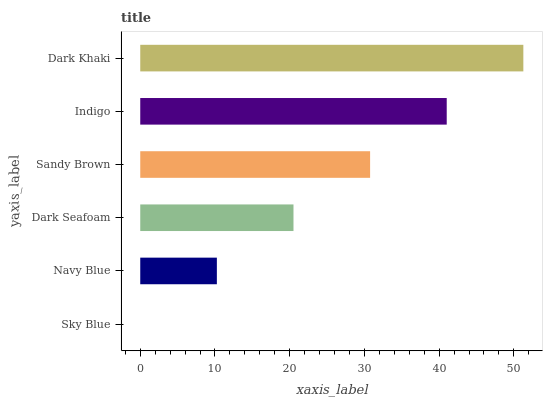Is Sky Blue the minimum?
Answer yes or no. Yes. Is Dark Khaki the maximum?
Answer yes or no. Yes. Is Navy Blue the minimum?
Answer yes or no. No. Is Navy Blue the maximum?
Answer yes or no. No. Is Navy Blue greater than Sky Blue?
Answer yes or no. Yes. Is Sky Blue less than Navy Blue?
Answer yes or no. Yes. Is Sky Blue greater than Navy Blue?
Answer yes or no. No. Is Navy Blue less than Sky Blue?
Answer yes or no. No. Is Sandy Brown the high median?
Answer yes or no. Yes. Is Dark Seafoam the low median?
Answer yes or no. Yes. Is Navy Blue the high median?
Answer yes or no. No. Is Sky Blue the low median?
Answer yes or no. No. 